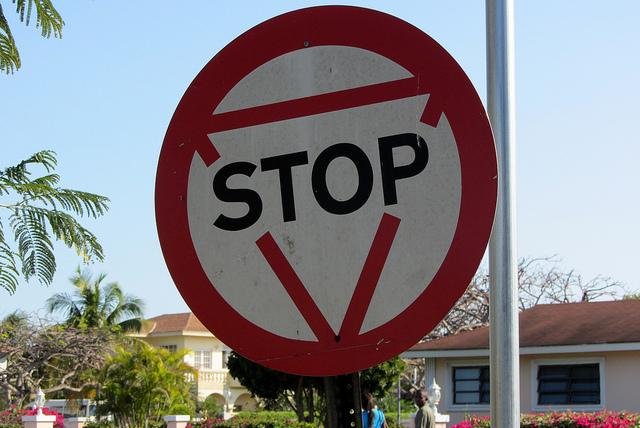What does the sign say?
Write a very short answer. Stop. What shape is the inner object inside the STOP sign?
Concise answer only. Triangle. Is the stop sign square shaped?
Quick response, please. No. 